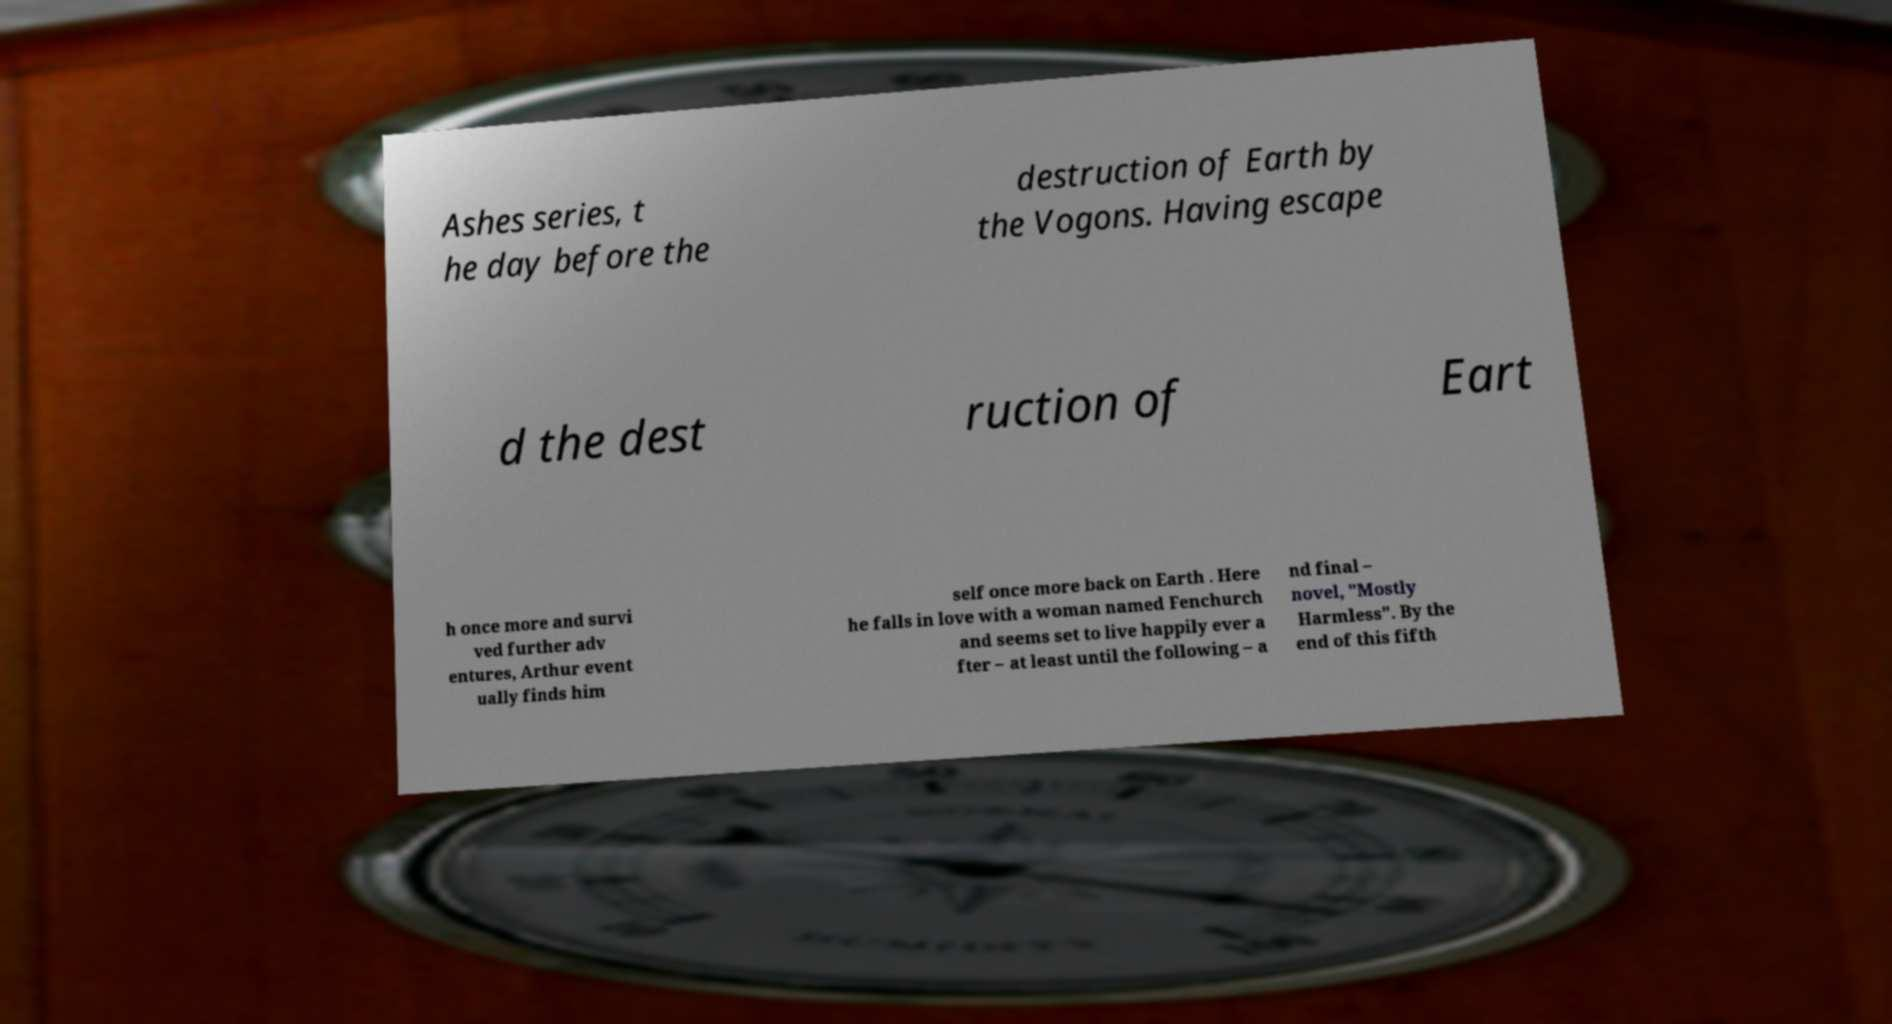Please identify and transcribe the text found in this image. Ashes series, t he day before the destruction of Earth by the Vogons. Having escape d the dest ruction of Eart h once more and survi ved further adv entures, Arthur event ually finds him self once more back on Earth . Here he falls in love with a woman named Fenchurch and seems set to live happily ever a fter – at least until the following – a nd final – novel, "Mostly Harmless". By the end of this fifth 